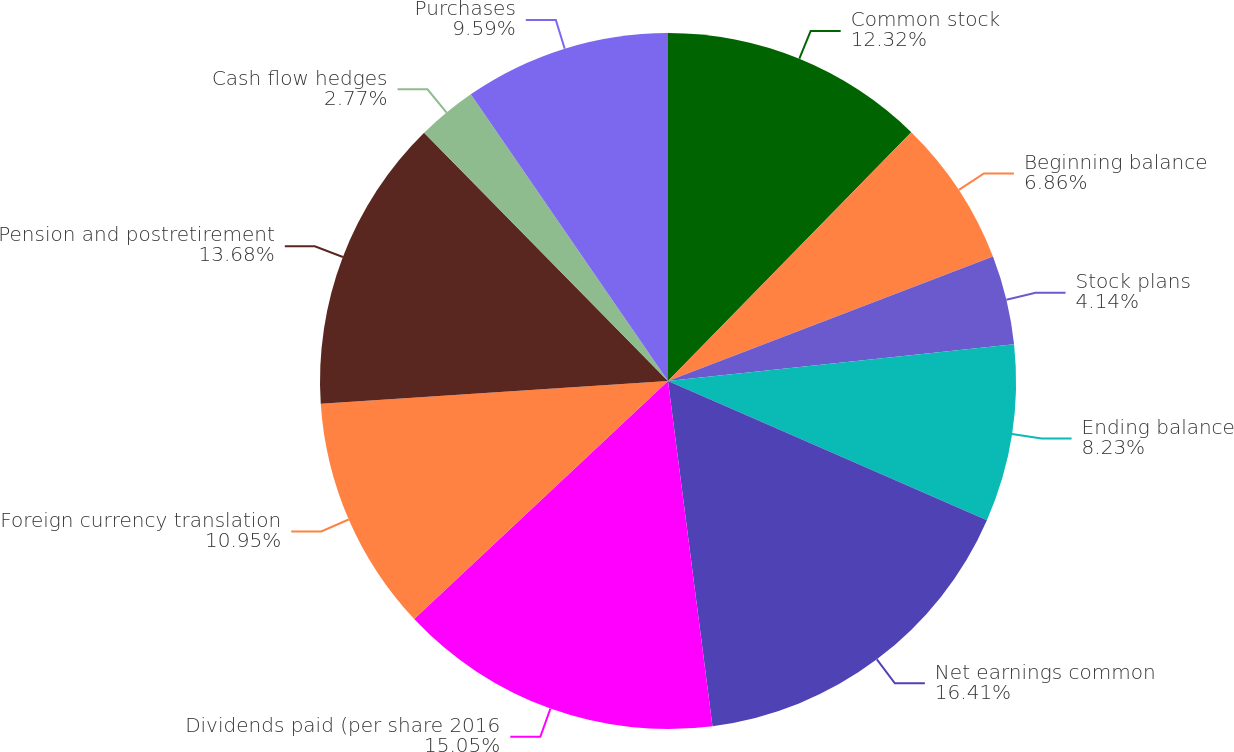Convert chart. <chart><loc_0><loc_0><loc_500><loc_500><pie_chart><fcel>Common stock<fcel>Beginning balance<fcel>Stock plans<fcel>Ending balance<fcel>Net earnings common<fcel>Dividends paid (per share 2016<fcel>Foreign currency translation<fcel>Pension and postretirement<fcel>Cash flow hedges<fcel>Purchases<nl><fcel>12.32%<fcel>6.86%<fcel>4.14%<fcel>8.23%<fcel>16.41%<fcel>15.05%<fcel>10.95%<fcel>13.68%<fcel>2.77%<fcel>9.59%<nl></chart> 